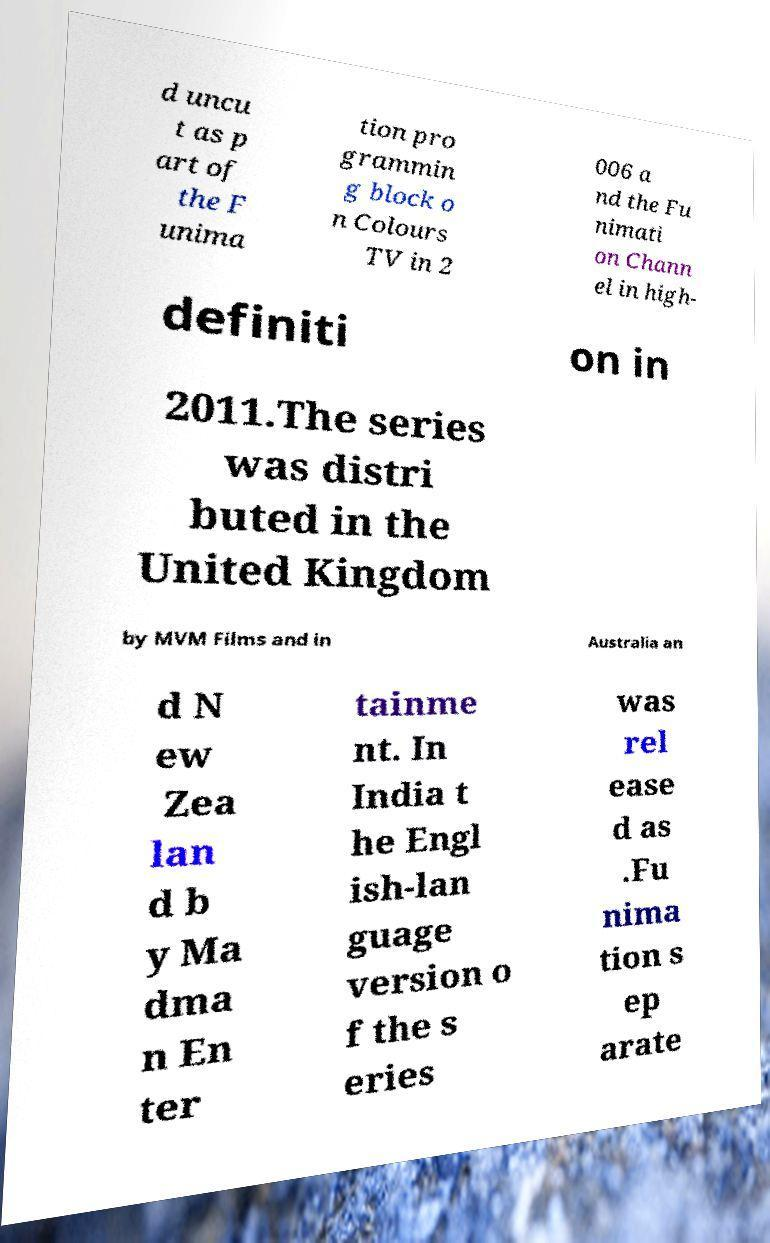Could you extract and type out the text from this image? d uncu t as p art of the F unima tion pro grammin g block o n Colours TV in 2 006 a nd the Fu nimati on Chann el in high- definiti on in 2011.The series was distri buted in the United Kingdom by MVM Films and in Australia an d N ew Zea lan d b y Ma dma n En ter tainme nt. In India t he Engl ish-lan guage version o f the s eries was rel ease d as .Fu nima tion s ep arate 